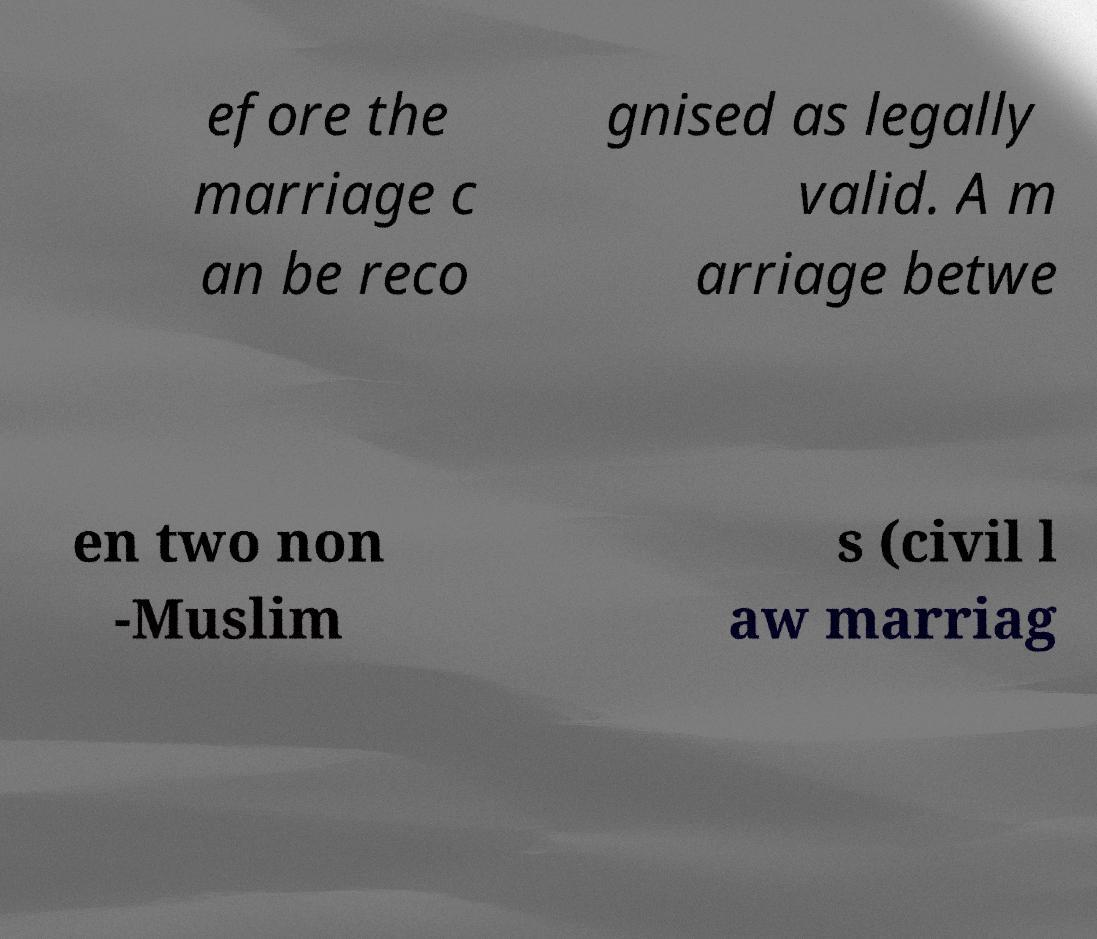I need the written content from this picture converted into text. Can you do that? efore the marriage c an be reco gnised as legally valid. A m arriage betwe en two non -Muslim s (civil l aw marriag 